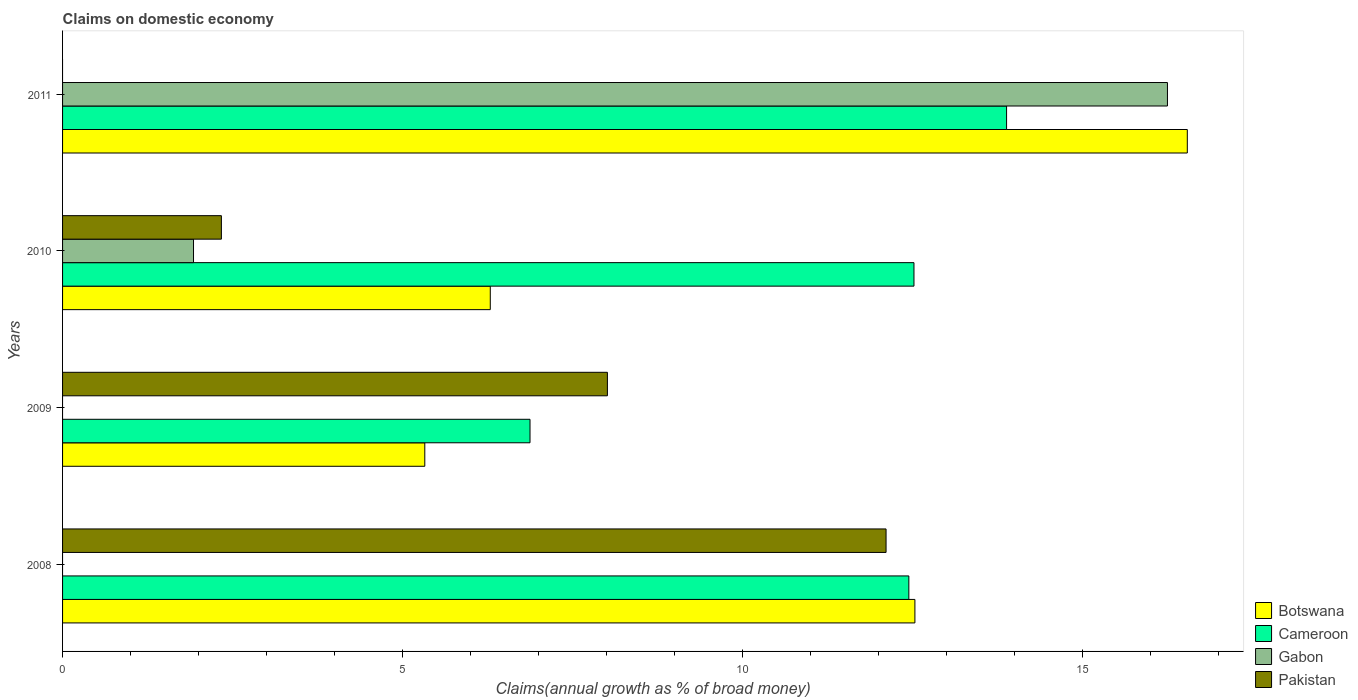How many groups of bars are there?
Ensure brevity in your answer.  4. Are the number of bars on each tick of the Y-axis equal?
Provide a short and direct response. No. How many bars are there on the 2nd tick from the bottom?
Offer a very short reply. 3. What is the percentage of broad money claimed on domestic economy in Cameroon in 2011?
Ensure brevity in your answer.  13.88. Across all years, what is the maximum percentage of broad money claimed on domestic economy in Pakistan?
Give a very brief answer. 12.11. What is the total percentage of broad money claimed on domestic economy in Pakistan in the graph?
Ensure brevity in your answer.  22.45. What is the difference between the percentage of broad money claimed on domestic economy in Pakistan in 2008 and that in 2010?
Offer a very short reply. 9.77. What is the difference between the percentage of broad money claimed on domestic economy in Gabon in 2010 and the percentage of broad money claimed on domestic economy in Pakistan in 2011?
Ensure brevity in your answer.  1.93. What is the average percentage of broad money claimed on domestic economy in Gabon per year?
Your answer should be very brief. 4.54. In the year 2008, what is the difference between the percentage of broad money claimed on domestic economy in Cameroon and percentage of broad money claimed on domestic economy in Pakistan?
Keep it short and to the point. 0.33. What is the ratio of the percentage of broad money claimed on domestic economy in Botswana in 2008 to that in 2011?
Ensure brevity in your answer.  0.76. What is the difference between the highest and the second highest percentage of broad money claimed on domestic economy in Botswana?
Your answer should be compact. 4. What is the difference between the highest and the lowest percentage of broad money claimed on domestic economy in Gabon?
Ensure brevity in your answer.  16.24. Is it the case that in every year, the sum of the percentage of broad money claimed on domestic economy in Cameroon and percentage of broad money claimed on domestic economy in Botswana is greater than the percentage of broad money claimed on domestic economy in Pakistan?
Keep it short and to the point. Yes. How many years are there in the graph?
Your answer should be very brief. 4. Are the values on the major ticks of X-axis written in scientific E-notation?
Give a very brief answer. No. Does the graph contain grids?
Provide a succinct answer. No. How many legend labels are there?
Give a very brief answer. 4. How are the legend labels stacked?
Your response must be concise. Vertical. What is the title of the graph?
Provide a succinct answer. Claims on domestic economy. What is the label or title of the X-axis?
Your response must be concise. Claims(annual growth as % of broad money). What is the label or title of the Y-axis?
Your response must be concise. Years. What is the Claims(annual growth as % of broad money) in Botswana in 2008?
Provide a short and direct response. 12.53. What is the Claims(annual growth as % of broad money) in Cameroon in 2008?
Offer a terse response. 12.44. What is the Claims(annual growth as % of broad money) of Gabon in 2008?
Offer a terse response. 0. What is the Claims(annual growth as % of broad money) of Pakistan in 2008?
Provide a short and direct response. 12.11. What is the Claims(annual growth as % of broad money) in Botswana in 2009?
Ensure brevity in your answer.  5.33. What is the Claims(annual growth as % of broad money) of Cameroon in 2009?
Your answer should be very brief. 6.87. What is the Claims(annual growth as % of broad money) of Gabon in 2009?
Your answer should be compact. 0. What is the Claims(annual growth as % of broad money) in Pakistan in 2009?
Give a very brief answer. 8.01. What is the Claims(annual growth as % of broad money) in Botswana in 2010?
Ensure brevity in your answer.  6.29. What is the Claims(annual growth as % of broad money) of Cameroon in 2010?
Provide a short and direct response. 12.52. What is the Claims(annual growth as % of broad money) of Gabon in 2010?
Your response must be concise. 1.93. What is the Claims(annual growth as % of broad money) in Pakistan in 2010?
Make the answer very short. 2.33. What is the Claims(annual growth as % of broad money) in Botswana in 2011?
Provide a succinct answer. 16.54. What is the Claims(annual growth as % of broad money) of Cameroon in 2011?
Give a very brief answer. 13.88. What is the Claims(annual growth as % of broad money) of Gabon in 2011?
Your response must be concise. 16.24. What is the Claims(annual growth as % of broad money) in Pakistan in 2011?
Give a very brief answer. 0. Across all years, what is the maximum Claims(annual growth as % of broad money) in Botswana?
Make the answer very short. 16.54. Across all years, what is the maximum Claims(annual growth as % of broad money) of Cameroon?
Your answer should be compact. 13.88. Across all years, what is the maximum Claims(annual growth as % of broad money) in Gabon?
Your answer should be very brief. 16.24. Across all years, what is the maximum Claims(annual growth as % of broad money) of Pakistan?
Keep it short and to the point. 12.11. Across all years, what is the minimum Claims(annual growth as % of broad money) in Botswana?
Your answer should be compact. 5.33. Across all years, what is the minimum Claims(annual growth as % of broad money) in Cameroon?
Provide a succinct answer. 6.87. What is the total Claims(annual growth as % of broad money) in Botswana in the graph?
Your answer should be compact. 40.68. What is the total Claims(annual growth as % of broad money) in Cameroon in the graph?
Give a very brief answer. 45.71. What is the total Claims(annual growth as % of broad money) of Gabon in the graph?
Offer a very short reply. 18.17. What is the total Claims(annual growth as % of broad money) in Pakistan in the graph?
Your answer should be very brief. 22.45. What is the difference between the Claims(annual growth as % of broad money) of Botswana in 2008 and that in 2009?
Your answer should be very brief. 7.21. What is the difference between the Claims(annual growth as % of broad money) of Cameroon in 2008 and that in 2009?
Give a very brief answer. 5.57. What is the difference between the Claims(annual growth as % of broad money) of Pakistan in 2008 and that in 2009?
Ensure brevity in your answer.  4.1. What is the difference between the Claims(annual growth as % of broad money) in Botswana in 2008 and that in 2010?
Ensure brevity in your answer.  6.24. What is the difference between the Claims(annual growth as % of broad money) of Cameroon in 2008 and that in 2010?
Offer a very short reply. -0.08. What is the difference between the Claims(annual growth as % of broad money) of Pakistan in 2008 and that in 2010?
Offer a terse response. 9.77. What is the difference between the Claims(annual growth as % of broad money) of Botswana in 2008 and that in 2011?
Provide a succinct answer. -4. What is the difference between the Claims(annual growth as % of broad money) in Cameroon in 2008 and that in 2011?
Give a very brief answer. -1.44. What is the difference between the Claims(annual growth as % of broad money) of Botswana in 2009 and that in 2010?
Keep it short and to the point. -0.96. What is the difference between the Claims(annual growth as % of broad money) of Cameroon in 2009 and that in 2010?
Provide a succinct answer. -5.64. What is the difference between the Claims(annual growth as % of broad money) of Pakistan in 2009 and that in 2010?
Ensure brevity in your answer.  5.68. What is the difference between the Claims(annual growth as % of broad money) of Botswana in 2009 and that in 2011?
Make the answer very short. -11.21. What is the difference between the Claims(annual growth as % of broad money) in Cameroon in 2009 and that in 2011?
Your response must be concise. -7.01. What is the difference between the Claims(annual growth as % of broad money) of Botswana in 2010 and that in 2011?
Your answer should be very brief. -10.25. What is the difference between the Claims(annual growth as % of broad money) of Cameroon in 2010 and that in 2011?
Provide a succinct answer. -1.36. What is the difference between the Claims(annual growth as % of broad money) of Gabon in 2010 and that in 2011?
Your answer should be compact. -14.32. What is the difference between the Claims(annual growth as % of broad money) of Botswana in 2008 and the Claims(annual growth as % of broad money) of Cameroon in 2009?
Ensure brevity in your answer.  5.66. What is the difference between the Claims(annual growth as % of broad money) of Botswana in 2008 and the Claims(annual growth as % of broad money) of Pakistan in 2009?
Provide a short and direct response. 4.52. What is the difference between the Claims(annual growth as % of broad money) in Cameroon in 2008 and the Claims(annual growth as % of broad money) in Pakistan in 2009?
Make the answer very short. 4.43. What is the difference between the Claims(annual growth as % of broad money) in Botswana in 2008 and the Claims(annual growth as % of broad money) in Cameroon in 2010?
Offer a terse response. 0.01. What is the difference between the Claims(annual growth as % of broad money) in Botswana in 2008 and the Claims(annual growth as % of broad money) in Gabon in 2010?
Your answer should be compact. 10.61. What is the difference between the Claims(annual growth as % of broad money) of Botswana in 2008 and the Claims(annual growth as % of broad money) of Pakistan in 2010?
Ensure brevity in your answer.  10.2. What is the difference between the Claims(annual growth as % of broad money) in Cameroon in 2008 and the Claims(annual growth as % of broad money) in Gabon in 2010?
Your answer should be very brief. 10.52. What is the difference between the Claims(annual growth as % of broad money) in Cameroon in 2008 and the Claims(annual growth as % of broad money) in Pakistan in 2010?
Offer a terse response. 10.11. What is the difference between the Claims(annual growth as % of broad money) of Botswana in 2008 and the Claims(annual growth as % of broad money) of Cameroon in 2011?
Your answer should be compact. -1.35. What is the difference between the Claims(annual growth as % of broad money) in Botswana in 2008 and the Claims(annual growth as % of broad money) in Gabon in 2011?
Keep it short and to the point. -3.71. What is the difference between the Claims(annual growth as % of broad money) of Cameroon in 2008 and the Claims(annual growth as % of broad money) of Gabon in 2011?
Make the answer very short. -3.8. What is the difference between the Claims(annual growth as % of broad money) in Botswana in 2009 and the Claims(annual growth as % of broad money) in Cameroon in 2010?
Offer a terse response. -7.19. What is the difference between the Claims(annual growth as % of broad money) of Botswana in 2009 and the Claims(annual growth as % of broad money) of Gabon in 2010?
Keep it short and to the point. 3.4. What is the difference between the Claims(annual growth as % of broad money) of Botswana in 2009 and the Claims(annual growth as % of broad money) of Pakistan in 2010?
Your answer should be compact. 2.99. What is the difference between the Claims(annual growth as % of broad money) of Cameroon in 2009 and the Claims(annual growth as % of broad money) of Gabon in 2010?
Give a very brief answer. 4.95. What is the difference between the Claims(annual growth as % of broad money) in Cameroon in 2009 and the Claims(annual growth as % of broad money) in Pakistan in 2010?
Provide a succinct answer. 4.54. What is the difference between the Claims(annual growth as % of broad money) in Botswana in 2009 and the Claims(annual growth as % of broad money) in Cameroon in 2011?
Offer a very short reply. -8.55. What is the difference between the Claims(annual growth as % of broad money) in Botswana in 2009 and the Claims(annual growth as % of broad money) in Gabon in 2011?
Your answer should be very brief. -10.92. What is the difference between the Claims(annual growth as % of broad money) of Cameroon in 2009 and the Claims(annual growth as % of broad money) of Gabon in 2011?
Give a very brief answer. -9.37. What is the difference between the Claims(annual growth as % of broad money) of Botswana in 2010 and the Claims(annual growth as % of broad money) of Cameroon in 2011?
Offer a terse response. -7.59. What is the difference between the Claims(annual growth as % of broad money) in Botswana in 2010 and the Claims(annual growth as % of broad money) in Gabon in 2011?
Offer a very short reply. -9.96. What is the difference between the Claims(annual growth as % of broad money) of Cameroon in 2010 and the Claims(annual growth as % of broad money) of Gabon in 2011?
Your response must be concise. -3.73. What is the average Claims(annual growth as % of broad money) of Botswana per year?
Offer a terse response. 10.17. What is the average Claims(annual growth as % of broad money) of Cameroon per year?
Give a very brief answer. 11.43. What is the average Claims(annual growth as % of broad money) of Gabon per year?
Ensure brevity in your answer.  4.54. What is the average Claims(annual growth as % of broad money) of Pakistan per year?
Your answer should be very brief. 5.61. In the year 2008, what is the difference between the Claims(annual growth as % of broad money) of Botswana and Claims(annual growth as % of broad money) of Cameroon?
Make the answer very short. 0.09. In the year 2008, what is the difference between the Claims(annual growth as % of broad money) in Botswana and Claims(annual growth as % of broad money) in Pakistan?
Offer a very short reply. 0.42. In the year 2008, what is the difference between the Claims(annual growth as % of broad money) of Cameroon and Claims(annual growth as % of broad money) of Pakistan?
Give a very brief answer. 0.33. In the year 2009, what is the difference between the Claims(annual growth as % of broad money) in Botswana and Claims(annual growth as % of broad money) in Cameroon?
Give a very brief answer. -1.55. In the year 2009, what is the difference between the Claims(annual growth as % of broad money) in Botswana and Claims(annual growth as % of broad money) in Pakistan?
Offer a very short reply. -2.68. In the year 2009, what is the difference between the Claims(annual growth as % of broad money) of Cameroon and Claims(annual growth as % of broad money) of Pakistan?
Ensure brevity in your answer.  -1.14. In the year 2010, what is the difference between the Claims(annual growth as % of broad money) of Botswana and Claims(annual growth as % of broad money) of Cameroon?
Keep it short and to the point. -6.23. In the year 2010, what is the difference between the Claims(annual growth as % of broad money) of Botswana and Claims(annual growth as % of broad money) of Gabon?
Make the answer very short. 4.36. In the year 2010, what is the difference between the Claims(annual growth as % of broad money) in Botswana and Claims(annual growth as % of broad money) in Pakistan?
Your answer should be very brief. 3.95. In the year 2010, what is the difference between the Claims(annual growth as % of broad money) of Cameroon and Claims(annual growth as % of broad money) of Gabon?
Offer a terse response. 10.59. In the year 2010, what is the difference between the Claims(annual growth as % of broad money) in Cameroon and Claims(annual growth as % of broad money) in Pakistan?
Make the answer very short. 10.18. In the year 2010, what is the difference between the Claims(annual growth as % of broad money) of Gabon and Claims(annual growth as % of broad money) of Pakistan?
Offer a very short reply. -0.41. In the year 2011, what is the difference between the Claims(annual growth as % of broad money) of Botswana and Claims(annual growth as % of broad money) of Cameroon?
Your answer should be compact. 2.66. In the year 2011, what is the difference between the Claims(annual growth as % of broad money) in Botswana and Claims(annual growth as % of broad money) in Gabon?
Offer a very short reply. 0.29. In the year 2011, what is the difference between the Claims(annual growth as % of broad money) of Cameroon and Claims(annual growth as % of broad money) of Gabon?
Keep it short and to the point. -2.37. What is the ratio of the Claims(annual growth as % of broad money) of Botswana in 2008 to that in 2009?
Keep it short and to the point. 2.35. What is the ratio of the Claims(annual growth as % of broad money) of Cameroon in 2008 to that in 2009?
Provide a short and direct response. 1.81. What is the ratio of the Claims(annual growth as % of broad money) of Pakistan in 2008 to that in 2009?
Keep it short and to the point. 1.51. What is the ratio of the Claims(annual growth as % of broad money) of Botswana in 2008 to that in 2010?
Provide a short and direct response. 1.99. What is the ratio of the Claims(annual growth as % of broad money) in Cameroon in 2008 to that in 2010?
Keep it short and to the point. 0.99. What is the ratio of the Claims(annual growth as % of broad money) in Pakistan in 2008 to that in 2010?
Your response must be concise. 5.19. What is the ratio of the Claims(annual growth as % of broad money) in Botswana in 2008 to that in 2011?
Provide a succinct answer. 0.76. What is the ratio of the Claims(annual growth as % of broad money) in Cameroon in 2008 to that in 2011?
Your response must be concise. 0.9. What is the ratio of the Claims(annual growth as % of broad money) in Botswana in 2009 to that in 2010?
Provide a succinct answer. 0.85. What is the ratio of the Claims(annual growth as % of broad money) in Cameroon in 2009 to that in 2010?
Ensure brevity in your answer.  0.55. What is the ratio of the Claims(annual growth as % of broad money) of Pakistan in 2009 to that in 2010?
Give a very brief answer. 3.43. What is the ratio of the Claims(annual growth as % of broad money) in Botswana in 2009 to that in 2011?
Your response must be concise. 0.32. What is the ratio of the Claims(annual growth as % of broad money) of Cameroon in 2009 to that in 2011?
Provide a succinct answer. 0.5. What is the ratio of the Claims(annual growth as % of broad money) in Botswana in 2010 to that in 2011?
Your answer should be very brief. 0.38. What is the ratio of the Claims(annual growth as % of broad money) of Cameroon in 2010 to that in 2011?
Make the answer very short. 0.9. What is the ratio of the Claims(annual growth as % of broad money) in Gabon in 2010 to that in 2011?
Make the answer very short. 0.12. What is the difference between the highest and the second highest Claims(annual growth as % of broad money) in Botswana?
Your answer should be very brief. 4. What is the difference between the highest and the second highest Claims(annual growth as % of broad money) of Cameroon?
Your answer should be very brief. 1.36. What is the difference between the highest and the second highest Claims(annual growth as % of broad money) of Pakistan?
Your response must be concise. 4.1. What is the difference between the highest and the lowest Claims(annual growth as % of broad money) in Botswana?
Keep it short and to the point. 11.21. What is the difference between the highest and the lowest Claims(annual growth as % of broad money) of Cameroon?
Offer a terse response. 7.01. What is the difference between the highest and the lowest Claims(annual growth as % of broad money) of Gabon?
Provide a short and direct response. 16.24. What is the difference between the highest and the lowest Claims(annual growth as % of broad money) in Pakistan?
Your response must be concise. 12.11. 